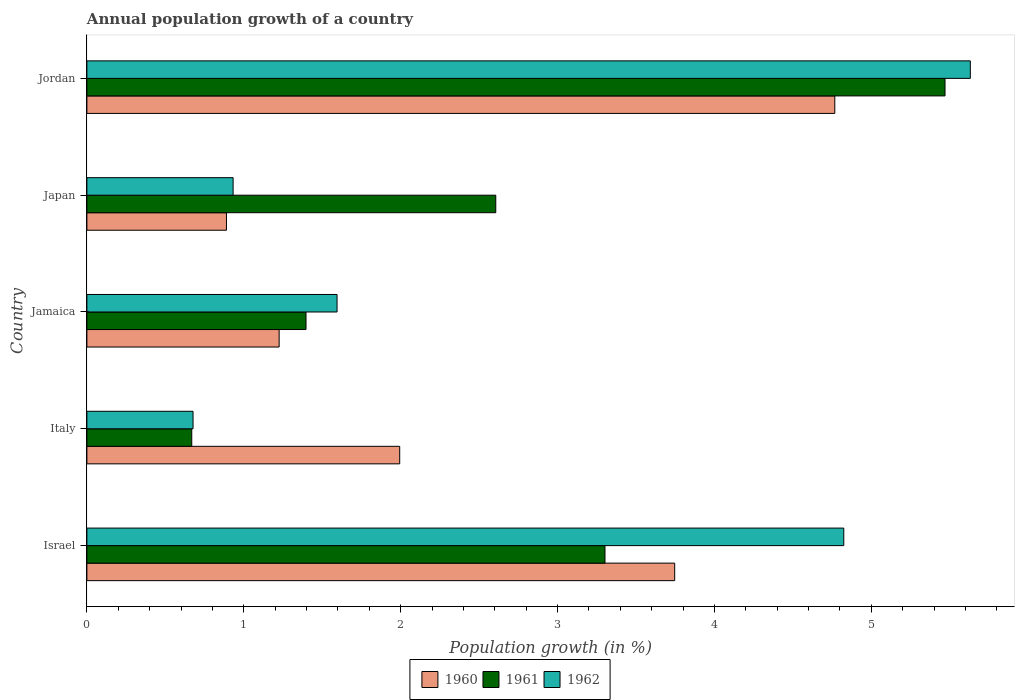How many different coloured bars are there?
Your answer should be very brief. 3. How many groups of bars are there?
Make the answer very short. 5. Are the number of bars per tick equal to the number of legend labels?
Provide a short and direct response. Yes. Are the number of bars on each tick of the Y-axis equal?
Your answer should be very brief. Yes. How many bars are there on the 2nd tick from the top?
Keep it short and to the point. 3. How many bars are there on the 5th tick from the bottom?
Provide a succinct answer. 3. What is the label of the 4th group of bars from the top?
Your answer should be very brief. Italy. What is the annual population growth in 1961 in Jamaica?
Provide a succinct answer. 1.4. Across all countries, what is the maximum annual population growth in 1962?
Keep it short and to the point. 5.63. Across all countries, what is the minimum annual population growth in 1960?
Provide a succinct answer. 0.89. In which country was the annual population growth in 1961 maximum?
Keep it short and to the point. Jordan. What is the total annual population growth in 1960 in the graph?
Your answer should be compact. 12.62. What is the difference between the annual population growth in 1962 in Italy and that in Jordan?
Offer a terse response. -4.95. What is the difference between the annual population growth in 1960 in Japan and the annual population growth in 1961 in Jordan?
Provide a succinct answer. -4.58. What is the average annual population growth in 1961 per country?
Ensure brevity in your answer.  2.69. What is the difference between the annual population growth in 1960 and annual population growth in 1962 in Jordan?
Your answer should be very brief. -0.86. In how many countries, is the annual population growth in 1962 greater than 1.4 %?
Keep it short and to the point. 3. What is the ratio of the annual population growth in 1960 in Italy to that in Jamaica?
Your response must be concise. 1.63. What is the difference between the highest and the second highest annual population growth in 1960?
Provide a short and direct response. 1.02. What is the difference between the highest and the lowest annual population growth in 1960?
Offer a terse response. 3.88. In how many countries, is the annual population growth in 1960 greater than the average annual population growth in 1960 taken over all countries?
Give a very brief answer. 2. Is the sum of the annual population growth in 1961 in Israel and Jordan greater than the maximum annual population growth in 1962 across all countries?
Your answer should be very brief. Yes. What does the 1st bar from the top in Israel represents?
Your response must be concise. 1962. Is it the case that in every country, the sum of the annual population growth in 1961 and annual population growth in 1962 is greater than the annual population growth in 1960?
Ensure brevity in your answer.  No. How many bars are there?
Provide a succinct answer. 15. How many countries are there in the graph?
Give a very brief answer. 5. Are the values on the major ticks of X-axis written in scientific E-notation?
Offer a very short reply. No. Does the graph contain any zero values?
Provide a succinct answer. No. Does the graph contain grids?
Give a very brief answer. No. How many legend labels are there?
Keep it short and to the point. 3. How are the legend labels stacked?
Offer a very short reply. Horizontal. What is the title of the graph?
Give a very brief answer. Annual population growth of a country. What is the label or title of the X-axis?
Offer a terse response. Population growth (in %). What is the Population growth (in %) of 1960 in Israel?
Provide a succinct answer. 3.75. What is the Population growth (in %) in 1961 in Israel?
Your response must be concise. 3.3. What is the Population growth (in %) in 1962 in Israel?
Offer a very short reply. 4.82. What is the Population growth (in %) of 1960 in Italy?
Make the answer very short. 1.99. What is the Population growth (in %) of 1961 in Italy?
Your answer should be very brief. 0.67. What is the Population growth (in %) of 1962 in Italy?
Offer a terse response. 0.68. What is the Population growth (in %) of 1960 in Jamaica?
Give a very brief answer. 1.23. What is the Population growth (in %) of 1961 in Jamaica?
Keep it short and to the point. 1.4. What is the Population growth (in %) in 1962 in Jamaica?
Ensure brevity in your answer.  1.59. What is the Population growth (in %) of 1960 in Japan?
Your answer should be compact. 0.89. What is the Population growth (in %) of 1961 in Japan?
Your answer should be compact. 2.61. What is the Population growth (in %) in 1962 in Japan?
Your answer should be very brief. 0.93. What is the Population growth (in %) of 1960 in Jordan?
Your response must be concise. 4.77. What is the Population growth (in %) in 1961 in Jordan?
Keep it short and to the point. 5.47. What is the Population growth (in %) of 1962 in Jordan?
Your answer should be very brief. 5.63. Across all countries, what is the maximum Population growth (in %) in 1960?
Your answer should be very brief. 4.77. Across all countries, what is the maximum Population growth (in %) in 1961?
Your answer should be very brief. 5.47. Across all countries, what is the maximum Population growth (in %) in 1962?
Offer a terse response. 5.63. Across all countries, what is the minimum Population growth (in %) of 1960?
Your response must be concise. 0.89. Across all countries, what is the minimum Population growth (in %) of 1961?
Make the answer very short. 0.67. Across all countries, what is the minimum Population growth (in %) of 1962?
Your answer should be very brief. 0.68. What is the total Population growth (in %) of 1960 in the graph?
Your answer should be very brief. 12.62. What is the total Population growth (in %) of 1961 in the graph?
Keep it short and to the point. 13.44. What is the total Population growth (in %) of 1962 in the graph?
Your response must be concise. 13.66. What is the difference between the Population growth (in %) of 1960 in Israel and that in Italy?
Keep it short and to the point. 1.75. What is the difference between the Population growth (in %) in 1961 in Israel and that in Italy?
Ensure brevity in your answer.  2.63. What is the difference between the Population growth (in %) of 1962 in Israel and that in Italy?
Your answer should be very brief. 4.15. What is the difference between the Population growth (in %) of 1960 in Israel and that in Jamaica?
Keep it short and to the point. 2.52. What is the difference between the Population growth (in %) of 1961 in Israel and that in Jamaica?
Provide a succinct answer. 1.91. What is the difference between the Population growth (in %) in 1962 in Israel and that in Jamaica?
Provide a short and direct response. 3.23. What is the difference between the Population growth (in %) in 1960 in Israel and that in Japan?
Provide a short and direct response. 2.86. What is the difference between the Population growth (in %) of 1961 in Israel and that in Japan?
Your answer should be compact. 0.7. What is the difference between the Population growth (in %) of 1962 in Israel and that in Japan?
Keep it short and to the point. 3.89. What is the difference between the Population growth (in %) of 1960 in Israel and that in Jordan?
Your answer should be compact. -1.02. What is the difference between the Population growth (in %) of 1961 in Israel and that in Jordan?
Make the answer very short. -2.17. What is the difference between the Population growth (in %) of 1962 in Israel and that in Jordan?
Offer a terse response. -0.81. What is the difference between the Population growth (in %) of 1960 in Italy and that in Jamaica?
Your answer should be very brief. 0.77. What is the difference between the Population growth (in %) of 1961 in Italy and that in Jamaica?
Give a very brief answer. -0.73. What is the difference between the Population growth (in %) in 1962 in Italy and that in Jamaica?
Provide a succinct answer. -0.92. What is the difference between the Population growth (in %) in 1960 in Italy and that in Japan?
Provide a succinct answer. 1.1. What is the difference between the Population growth (in %) of 1961 in Italy and that in Japan?
Give a very brief answer. -1.94. What is the difference between the Population growth (in %) of 1962 in Italy and that in Japan?
Offer a terse response. -0.26. What is the difference between the Population growth (in %) in 1960 in Italy and that in Jordan?
Offer a very short reply. -2.77. What is the difference between the Population growth (in %) in 1961 in Italy and that in Jordan?
Ensure brevity in your answer.  -4.8. What is the difference between the Population growth (in %) of 1962 in Italy and that in Jordan?
Your response must be concise. -4.95. What is the difference between the Population growth (in %) in 1960 in Jamaica and that in Japan?
Make the answer very short. 0.34. What is the difference between the Population growth (in %) of 1961 in Jamaica and that in Japan?
Your answer should be very brief. -1.21. What is the difference between the Population growth (in %) of 1962 in Jamaica and that in Japan?
Keep it short and to the point. 0.66. What is the difference between the Population growth (in %) in 1960 in Jamaica and that in Jordan?
Your answer should be very brief. -3.54. What is the difference between the Population growth (in %) of 1961 in Jamaica and that in Jordan?
Provide a succinct answer. -4.07. What is the difference between the Population growth (in %) in 1962 in Jamaica and that in Jordan?
Ensure brevity in your answer.  -4.04. What is the difference between the Population growth (in %) in 1960 in Japan and that in Jordan?
Offer a very short reply. -3.88. What is the difference between the Population growth (in %) of 1961 in Japan and that in Jordan?
Offer a terse response. -2.86. What is the difference between the Population growth (in %) of 1962 in Japan and that in Jordan?
Provide a succinct answer. -4.7. What is the difference between the Population growth (in %) in 1960 in Israel and the Population growth (in %) in 1961 in Italy?
Offer a very short reply. 3.08. What is the difference between the Population growth (in %) of 1960 in Israel and the Population growth (in %) of 1962 in Italy?
Offer a terse response. 3.07. What is the difference between the Population growth (in %) of 1961 in Israel and the Population growth (in %) of 1962 in Italy?
Keep it short and to the point. 2.63. What is the difference between the Population growth (in %) in 1960 in Israel and the Population growth (in %) in 1961 in Jamaica?
Make the answer very short. 2.35. What is the difference between the Population growth (in %) in 1960 in Israel and the Population growth (in %) in 1962 in Jamaica?
Make the answer very short. 2.15. What is the difference between the Population growth (in %) of 1961 in Israel and the Population growth (in %) of 1962 in Jamaica?
Give a very brief answer. 1.71. What is the difference between the Population growth (in %) in 1960 in Israel and the Population growth (in %) in 1961 in Japan?
Give a very brief answer. 1.14. What is the difference between the Population growth (in %) of 1960 in Israel and the Population growth (in %) of 1962 in Japan?
Offer a terse response. 2.81. What is the difference between the Population growth (in %) in 1961 in Israel and the Population growth (in %) in 1962 in Japan?
Your answer should be very brief. 2.37. What is the difference between the Population growth (in %) in 1960 in Israel and the Population growth (in %) in 1961 in Jordan?
Offer a very short reply. -1.72. What is the difference between the Population growth (in %) of 1960 in Israel and the Population growth (in %) of 1962 in Jordan?
Your answer should be very brief. -1.88. What is the difference between the Population growth (in %) of 1961 in Israel and the Population growth (in %) of 1962 in Jordan?
Ensure brevity in your answer.  -2.33. What is the difference between the Population growth (in %) of 1960 in Italy and the Population growth (in %) of 1961 in Jamaica?
Offer a very short reply. 0.6. What is the difference between the Population growth (in %) in 1960 in Italy and the Population growth (in %) in 1962 in Jamaica?
Keep it short and to the point. 0.4. What is the difference between the Population growth (in %) in 1961 in Italy and the Population growth (in %) in 1962 in Jamaica?
Your answer should be compact. -0.93. What is the difference between the Population growth (in %) of 1960 in Italy and the Population growth (in %) of 1961 in Japan?
Offer a very short reply. -0.61. What is the difference between the Population growth (in %) of 1960 in Italy and the Population growth (in %) of 1962 in Japan?
Give a very brief answer. 1.06. What is the difference between the Population growth (in %) in 1961 in Italy and the Population growth (in %) in 1962 in Japan?
Offer a very short reply. -0.26. What is the difference between the Population growth (in %) of 1960 in Italy and the Population growth (in %) of 1961 in Jordan?
Offer a very short reply. -3.48. What is the difference between the Population growth (in %) in 1960 in Italy and the Population growth (in %) in 1962 in Jordan?
Provide a succinct answer. -3.64. What is the difference between the Population growth (in %) of 1961 in Italy and the Population growth (in %) of 1962 in Jordan?
Give a very brief answer. -4.96. What is the difference between the Population growth (in %) of 1960 in Jamaica and the Population growth (in %) of 1961 in Japan?
Your response must be concise. -1.38. What is the difference between the Population growth (in %) of 1960 in Jamaica and the Population growth (in %) of 1962 in Japan?
Provide a short and direct response. 0.29. What is the difference between the Population growth (in %) in 1961 in Jamaica and the Population growth (in %) in 1962 in Japan?
Your answer should be very brief. 0.46. What is the difference between the Population growth (in %) of 1960 in Jamaica and the Population growth (in %) of 1961 in Jordan?
Your response must be concise. -4.24. What is the difference between the Population growth (in %) in 1960 in Jamaica and the Population growth (in %) in 1962 in Jordan?
Make the answer very short. -4.41. What is the difference between the Population growth (in %) in 1961 in Jamaica and the Population growth (in %) in 1962 in Jordan?
Your response must be concise. -4.23. What is the difference between the Population growth (in %) of 1960 in Japan and the Population growth (in %) of 1961 in Jordan?
Your response must be concise. -4.58. What is the difference between the Population growth (in %) of 1960 in Japan and the Population growth (in %) of 1962 in Jordan?
Provide a short and direct response. -4.74. What is the difference between the Population growth (in %) in 1961 in Japan and the Population growth (in %) in 1962 in Jordan?
Offer a very short reply. -3.02. What is the average Population growth (in %) in 1960 per country?
Offer a terse response. 2.52. What is the average Population growth (in %) in 1961 per country?
Your answer should be very brief. 2.69. What is the average Population growth (in %) of 1962 per country?
Keep it short and to the point. 2.73. What is the difference between the Population growth (in %) of 1960 and Population growth (in %) of 1961 in Israel?
Your answer should be very brief. 0.44. What is the difference between the Population growth (in %) in 1960 and Population growth (in %) in 1962 in Israel?
Offer a very short reply. -1.08. What is the difference between the Population growth (in %) in 1961 and Population growth (in %) in 1962 in Israel?
Your response must be concise. -1.52. What is the difference between the Population growth (in %) in 1960 and Population growth (in %) in 1961 in Italy?
Provide a short and direct response. 1.33. What is the difference between the Population growth (in %) in 1960 and Population growth (in %) in 1962 in Italy?
Your answer should be compact. 1.32. What is the difference between the Population growth (in %) of 1961 and Population growth (in %) of 1962 in Italy?
Offer a very short reply. -0.01. What is the difference between the Population growth (in %) in 1960 and Population growth (in %) in 1961 in Jamaica?
Offer a very short reply. -0.17. What is the difference between the Population growth (in %) of 1960 and Population growth (in %) of 1962 in Jamaica?
Provide a succinct answer. -0.37. What is the difference between the Population growth (in %) in 1961 and Population growth (in %) in 1962 in Jamaica?
Make the answer very short. -0.2. What is the difference between the Population growth (in %) in 1960 and Population growth (in %) in 1961 in Japan?
Keep it short and to the point. -1.72. What is the difference between the Population growth (in %) in 1960 and Population growth (in %) in 1962 in Japan?
Offer a terse response. -0.04. What is the difference between the Population growth (in %) of 1961 and Population growth (in %) of 1962 in Japan?
Provide a succinct answer. 1.67. What is the difference between the Population growth (in %) of 1960 and Population growth (in %) of 1961 in Jordan?
Offer a terse response. -0.7. What is the difference between the Population growth (in %) in 1960 and Population growth (in %) in 1962 in Jordan?
Your response must be concise. -0.86. What is the difference between the Population growth (in %) of 1961 and Population growth (in %) of 1962 in Jordan?
Give a very brief answer. -0.16. What is the ratio of the Population growth (in %) in 1960 in Israel to that in Italy?
Provide a succinct answer. 1.88. What is the ratio of the Population growth (in %) in 1961 in Israel to that in Italy?
Provide a succinct answer. 4.94. What is the ratio of the Population growth (in %) in 1962 in Israel to that in Italy?
Offer a terse response. 7.13. What is the ratio of the Population growth (in %) of 1960 in Israel to that in Jamaica?
Give a very brief answer. 3.06. What is the ratio of the Population growth (in %) of 1961 in Israel to that in Jamaica?
Make the answer very short. 2.36. What is the ratio of the Population growth (in %) of 1962 in Israel to that in Jamaica?
Provide a short and direct response. 3.03. What is the ratio of the Population growth (in %) of 1960 in Israel to that in Japan?
Your response must be concise. 4.21. What is the ratio of the Population growth (in %) of 1961 in Israel to that in Japan?
Keep it short and to the point. 1.27. What is the ratio of the Population growth (in %) in 1962 in Israel to that in Japan?
Offer a very short reply. 5.18. What is the ratio of the Population growth (in %) in 1960 in Israel to that in Jordan?
Your answer should be very brief. 0.79. What is the ratio of the Population growth (in %) of 1961 in Israel to that in Jordan?
Ensure brevity in your answer.  0.6. What is the ratio of the Population growth (in %) of 1962 in Israel to that in Jordan?
Ensure brevity in your answer.  0.86. What is the ratio of the Population growth (in %) of 1960 in Italy to that in Jamaica?
Offer a terse response. 1.63. What is the ratio of the Population growth (in %) in 1961 in Italy to that in Jamaica?
Provide a short and direct response. 0.48. What is the ratio of the Population growth (in %) of 1962 in Italy to that in Jamaica?
Your answer should be very brief. 0.42. What is the ratio of the Population growth (in %) of 1960 in Italy to that in Japan?
Your answer should be very brief. 2.24. What is the ratio of the Population growth (in %) in 1961 in Italy to that in Japan?
Your answer should be compact. 0.26. What is the ratio of the Population growth (in %) of 1962 in Italy to that in Japan?
Your answer should be compact. 0.73. What is the ratio of the Population growth (in %) of 1960 in Italy to that in Jordan?
Make the answer very short. 0.42. What is the ratio of the Population growth (in %) of 1961 in Italy to that in Jordan?
Your answer should be compact. 0.12. What is the ratio of the Population growth (in %) in 1962 in Italy to that in Jordan?
Your answer should be compact. 0.12. What is the ratio of the Population growth (in %) of 1960 in Jamaica to that in Japan?
Your answer should be compact. 1.38. What is the ratio of the Population growth (in %) of 1961 in Jamaica to that in Japan?
Your answer should be compact. 0.54. What is the ratio of the Population growth (in %) of 1962 in Jamaica to that in Japan?
Make the answer very short. 1.71. What is the ratio of the Population growth (in %) of 1960 in Jamaica to that in Jordan?
Your answer should be compact. 0.26. What is the ratio of the Population growth (in %) of 1961 in Jamaica to that in Jordan?
Your answer should be compact. 0.26. What is the ratio of the Population growth (in %) in 1962 in Jamaica to that in Jordan?
Keep it short and to the point. 0.28. What is the ratio of the Population growth (in %) of 1960 in Japan to that in Jordan?
Your response must be concise. 0.19. What is the ratio of the Population growth (in %) of 1961 in Japan to that in Jordan?
Ensure brevity in your answer.  0.48. What is the ratio of the Population growth (in %) in 1962 in Japan to that in Jordan?
Make the answer very short. 0.17. What is the difference between the highest and the second highest Population growth (in %) of 1960?
Make the answer very short. 1.02. What is the difference between the highest and the second highest Population growth (in %) in 1961?
Offer a very short reply. 2.17. What is the difference between the highest and the second highest Population growth (in %) of 1962?
Your answer should be very brief. 0.81. What is the difference between the highest and the lowest Population growth (in %) in 1960?
Offer a very short reply. 3.88. What is the difference between the highest and the lowest Population growth (in %) in 1961?
Ensure brevity in your answer.  4.8. What is the difference between the highest and the lowest Population growth (in %) in 1962?
Keep it short and to the point. 4.95. 